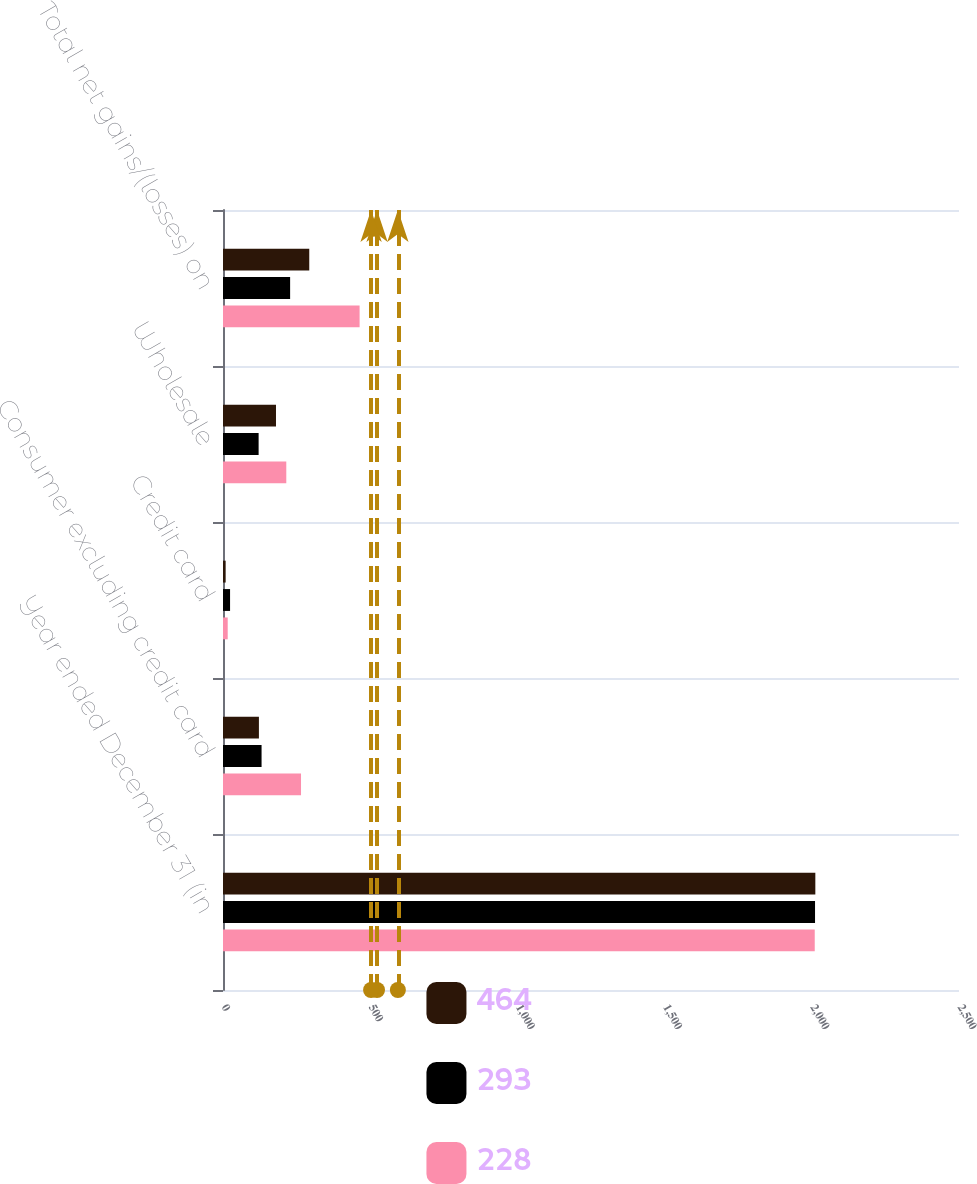Convert chart to OTSL. <chart><loc_0><loc_0><loc_500><loc_500><stacked_bar_chart><ecel><fcel>Year ended December 31 (in<fcel>Consumer excluding credit card<fcel>Credit card<fcel>Wholesale<fcel>Total net gains/(losses) on<nl><fcel>464<fcel>2012<fcel>122<fcel>9<fcel>180<fcel>293<nl><fcel>293<fcel>2011<fcel>131<fcel>24<fcel>121<fcel>228<nl><fcel>228<fcel>2010<fcel>265<fcel>16<fcel>215<fcel>464<nl></chart> 